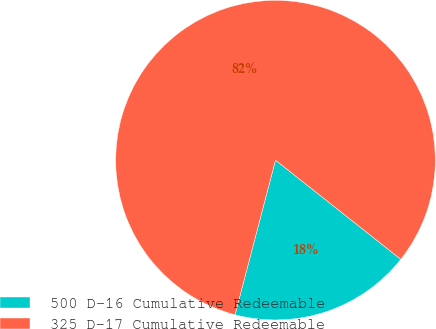Convert chart. <chart><loc_0><loc_0><loc_500><loc_500><pie_chart><fcel>500 D-16 Cumulative Redeemable<fcel>325 D-17 Cumulative Redeemable<nl><fcel>18.42%<fcel>81.58%<nl></chart> 